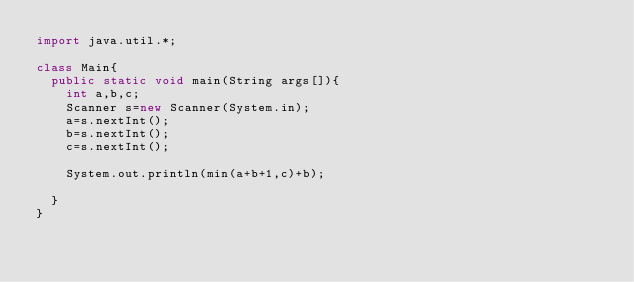<code> <loc_0><loc_0><loc_500><loc_500><_Java_>import java.util.*;

class Main{
  public static void main(String args[]){
    int a,b,c;
    Scanner s=new Scanner(System.in);
    a=s.nextInt();
    b=s.nextInt();
    c=s.nextInt();
    
    System.out.println(min(a+b+1,c)+b);
    
  }
}
    </code> 